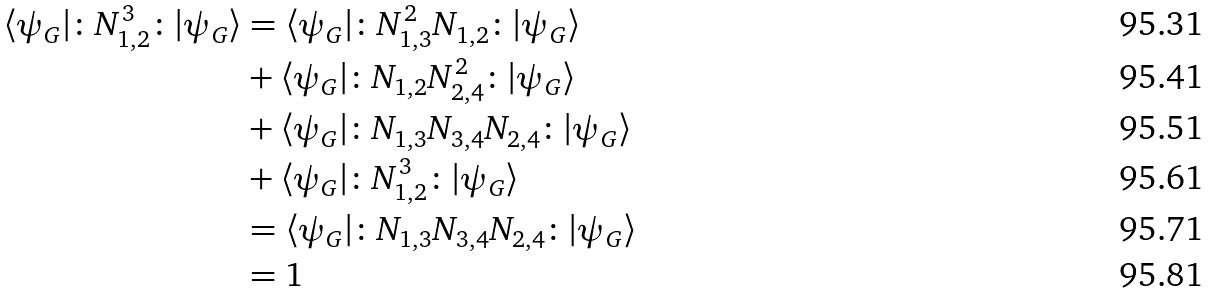Convert formula to latex. <formula><loc_0><loc_0><loc_500><loc_500>\langle \psi _ { G } | \colon N _ { 1 , 2 } ^ { 3 } \colon | \psi _ { G } \rangle & = \langle \psi _ { G } | \colon N _ { 1 , 3 } ^ { 2 } N _ { 1 , 2 } \colon | \psi _ { G } \rangle \\ & + \langle \psi _ { G } | \colon N _ { 1 , 2 } N _ { 2 , 4 } ^ { 2 } \colon | \psi _ { G } \rangle \\ & + \langle \psi _ { G } | \colon N _ { 1 , 3 } N _ { 3 , 4 } N _ { 2 , 4 } \colon | \psi _ { G } \rangle \\ & + \langle \psi _ { G } | \colon N _ { 1 , 2 } ^ { 3 } \colon | \psi _ { G } \rangle \\ & = \langle \psi _ { G } | \colon N _ { 1 , 3 } N _ { 3 , 4 } N _ { 2 , 4 } \colon | \psi _ { G } \rangle \\ & = 1</formula> 